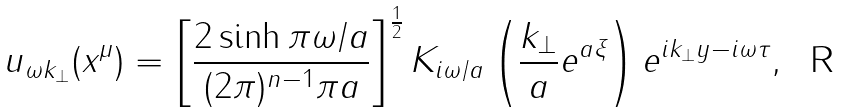Convert formula to latex. <formula><loc_0><loc_0><loc_500><loc_500>u _ { \omega { k } _ { \bot } } ( x ^ { \mu } ) = \left [ \frac { 2 \sinh \pi \omega / a } { ( 2 \pi ) ^ { n - 1 } \pi a } \right ] ^ { \frac { 1 } { 2 } } K _ { i \omega / a } \left ( \frac { k _ { \bot } } { a } e ^ { a \xi } \right ) e ^ { i { k } _ { \bot } { y } - i \omega \tau } ,</formula> 